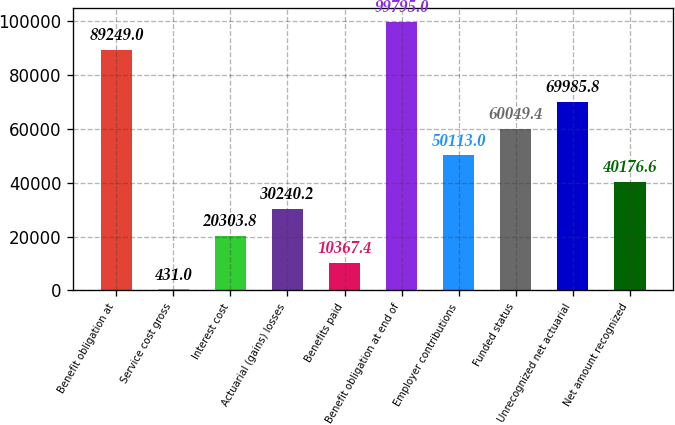<chart> <loc_0><loc_0><loc_500><loc_500><bar_chart><fcel>Benefit obligation at<fcel>Service cost gross<fcel>Interest cost<fcel>Actuarial (gains) losses<fcel>Benefits paid<fcel>Benefit obligation at end of<fcel>Employer contributions<fcel>Funded status<fcel>Unrecognized net actuarial<fcel>Net amount recognized<nl><fcel>89249<fcel>431<fcel>20303.8<fcel>30240.2<fcel>10367.4<fcel>99795<fcel>50113<fcel>60049.4<fcel>69985.8<fcel>40176.6<nl></chart> 